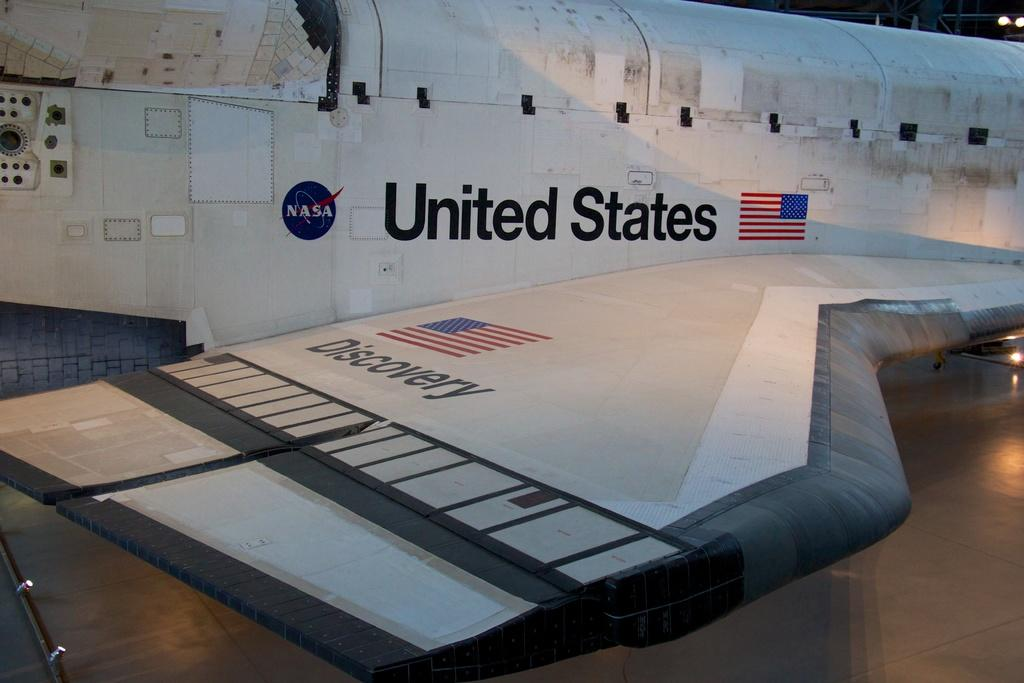<image>
Summarize the visual content of the image. The word discovery is below an American flag. 